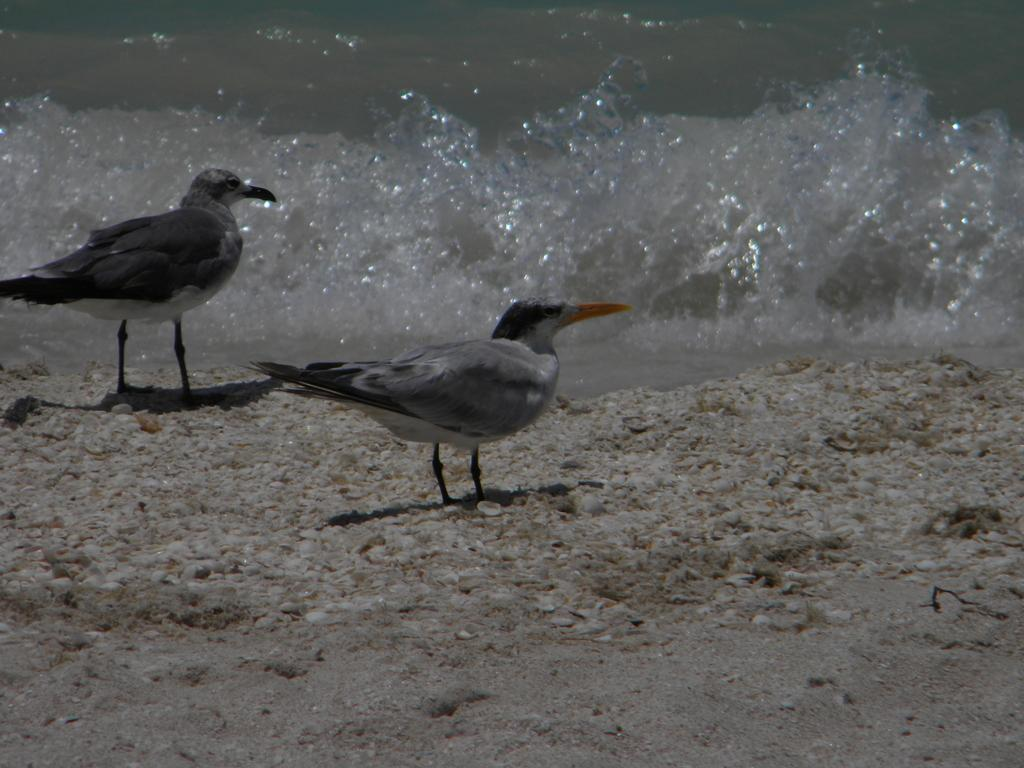How many birds are in the image? There are two birds in the image. Where are the birds located in the image? The birds are standing on the land. What else can be seen in the image besides the birds? There is water visible in the image. What is the condition of the water in the image? The water has tides at the top of the image. What type of party is being held in the image? There is no party present in the image; it features two birds standing on the land with water and tides visible. Can you provide a suggestion for improving the time management of the birds in the image? There is no need to provide a suggestion for improving the time management of the birds, as they are not engaged in any activity that requires time management. 